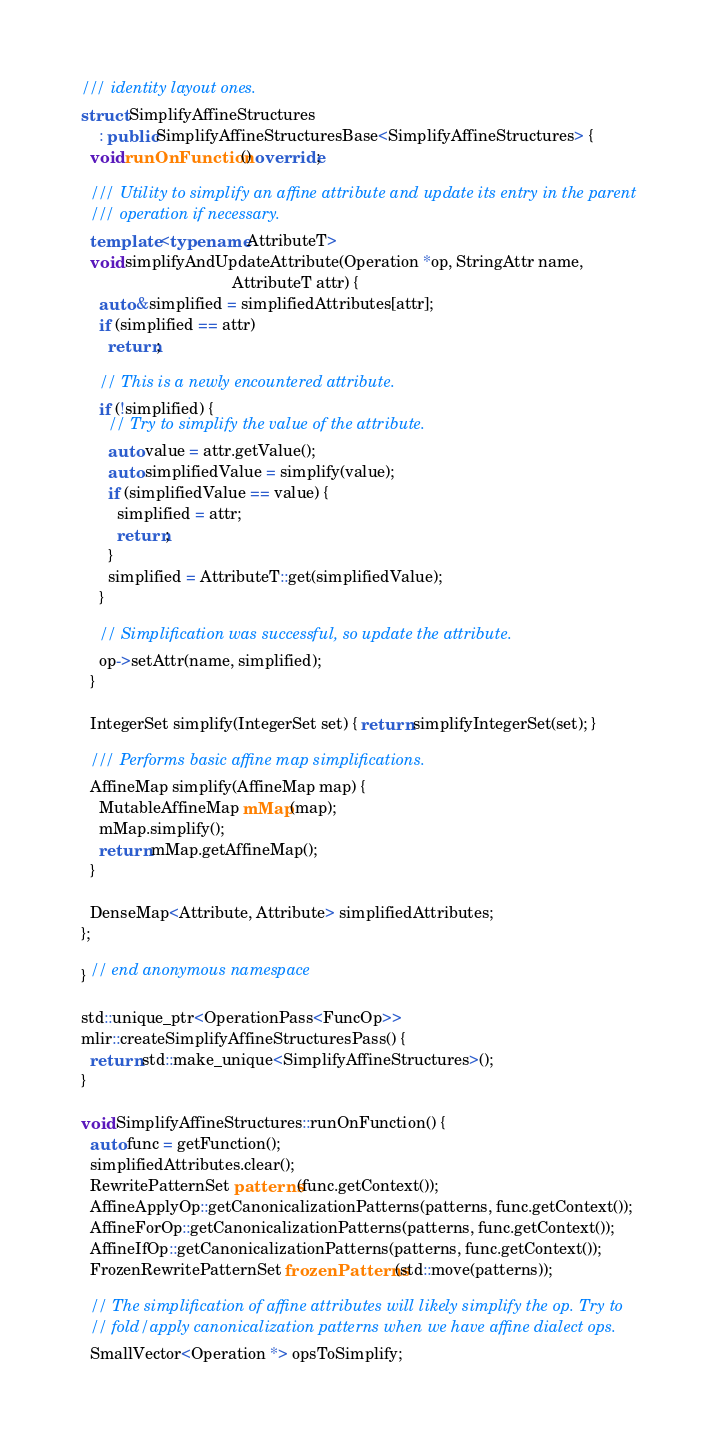<code> <loc_0><loc_0><loc_500><loc_500><_C++_>/// identity layout ones.
struct SimplifyAffineStructures
    : public SimplifyAffineStructuresBase<SimplifyAffineStructures> {
  void runOnFunction() override;

  /// Utility to simplify an affine attribute and update its entry in the parent
  /// operation if necessary.
  template <typename AttributeT>
  void simplifyAndUpdateAttribute(Operation *op, StringAttr name,
                                  AttributeT attr) {
    auto &simplified = simplifiedAttributes[attr];
    if (simplified == attr)
      return;

    // This is a newly encountered attribute.
    if (!simplified) {
      // Try to simplify the value of the attribute.
      auto value = attr.getValue();
      auto simplifiedValue = simplify(value);
      if (simplifiedValue == value) {
        simplified = attr;
        return;
      }
      simplified = AttributeT::get(simplifiedValue);
    }

    // Simplification was successful, so update the attribute.
    op->setAttr(name, simplified);
  }

  IntegerSet simplify(IntegerSet set) { return simplifyIntegerSet(set); }

  /// Performs basic affine map simplifications.
  AffineMap simplify(AffineMap map) {
    MutableAffineMap mMap(map);
    mMap.simplify();
    return mMap.getAffineMap();
  }

  DenseMap<Attribute, Attribute> simplifiedAttributes;
};

} // end anonymous namespace

std::unique_ptr<OperationPass<FuncOp>>
mlir::createSimplifyAffineStructuresPass() {
  return std::make_unique<SimplifyAffineStructures>();
}

void SimplifyAffineStructures::runOnFunction() {
  auto func = getFunction();
  simplifiedAttributes.clear();
  RewritePatternSet patterns(func.getContext());
  AffineApplyOp::getCanonicalizationPatterns(patterns, func.getContext());
  AffineForOp::getCanonicalizationPatterns(patterns, func.getContext());
  AffineIfOp::getCanonicalizationPatterns(patterns, func.getContext());
  FrozenRewritePatternSet frozenPatterns(std::move(patterns));

  // The simplification of affine attributes will likely simplify the op. Try to
  // fold/apply canonicalization patterns when we have affine dialect ops.
  SmallVector<Operation *> opsToSimplify;</code> 